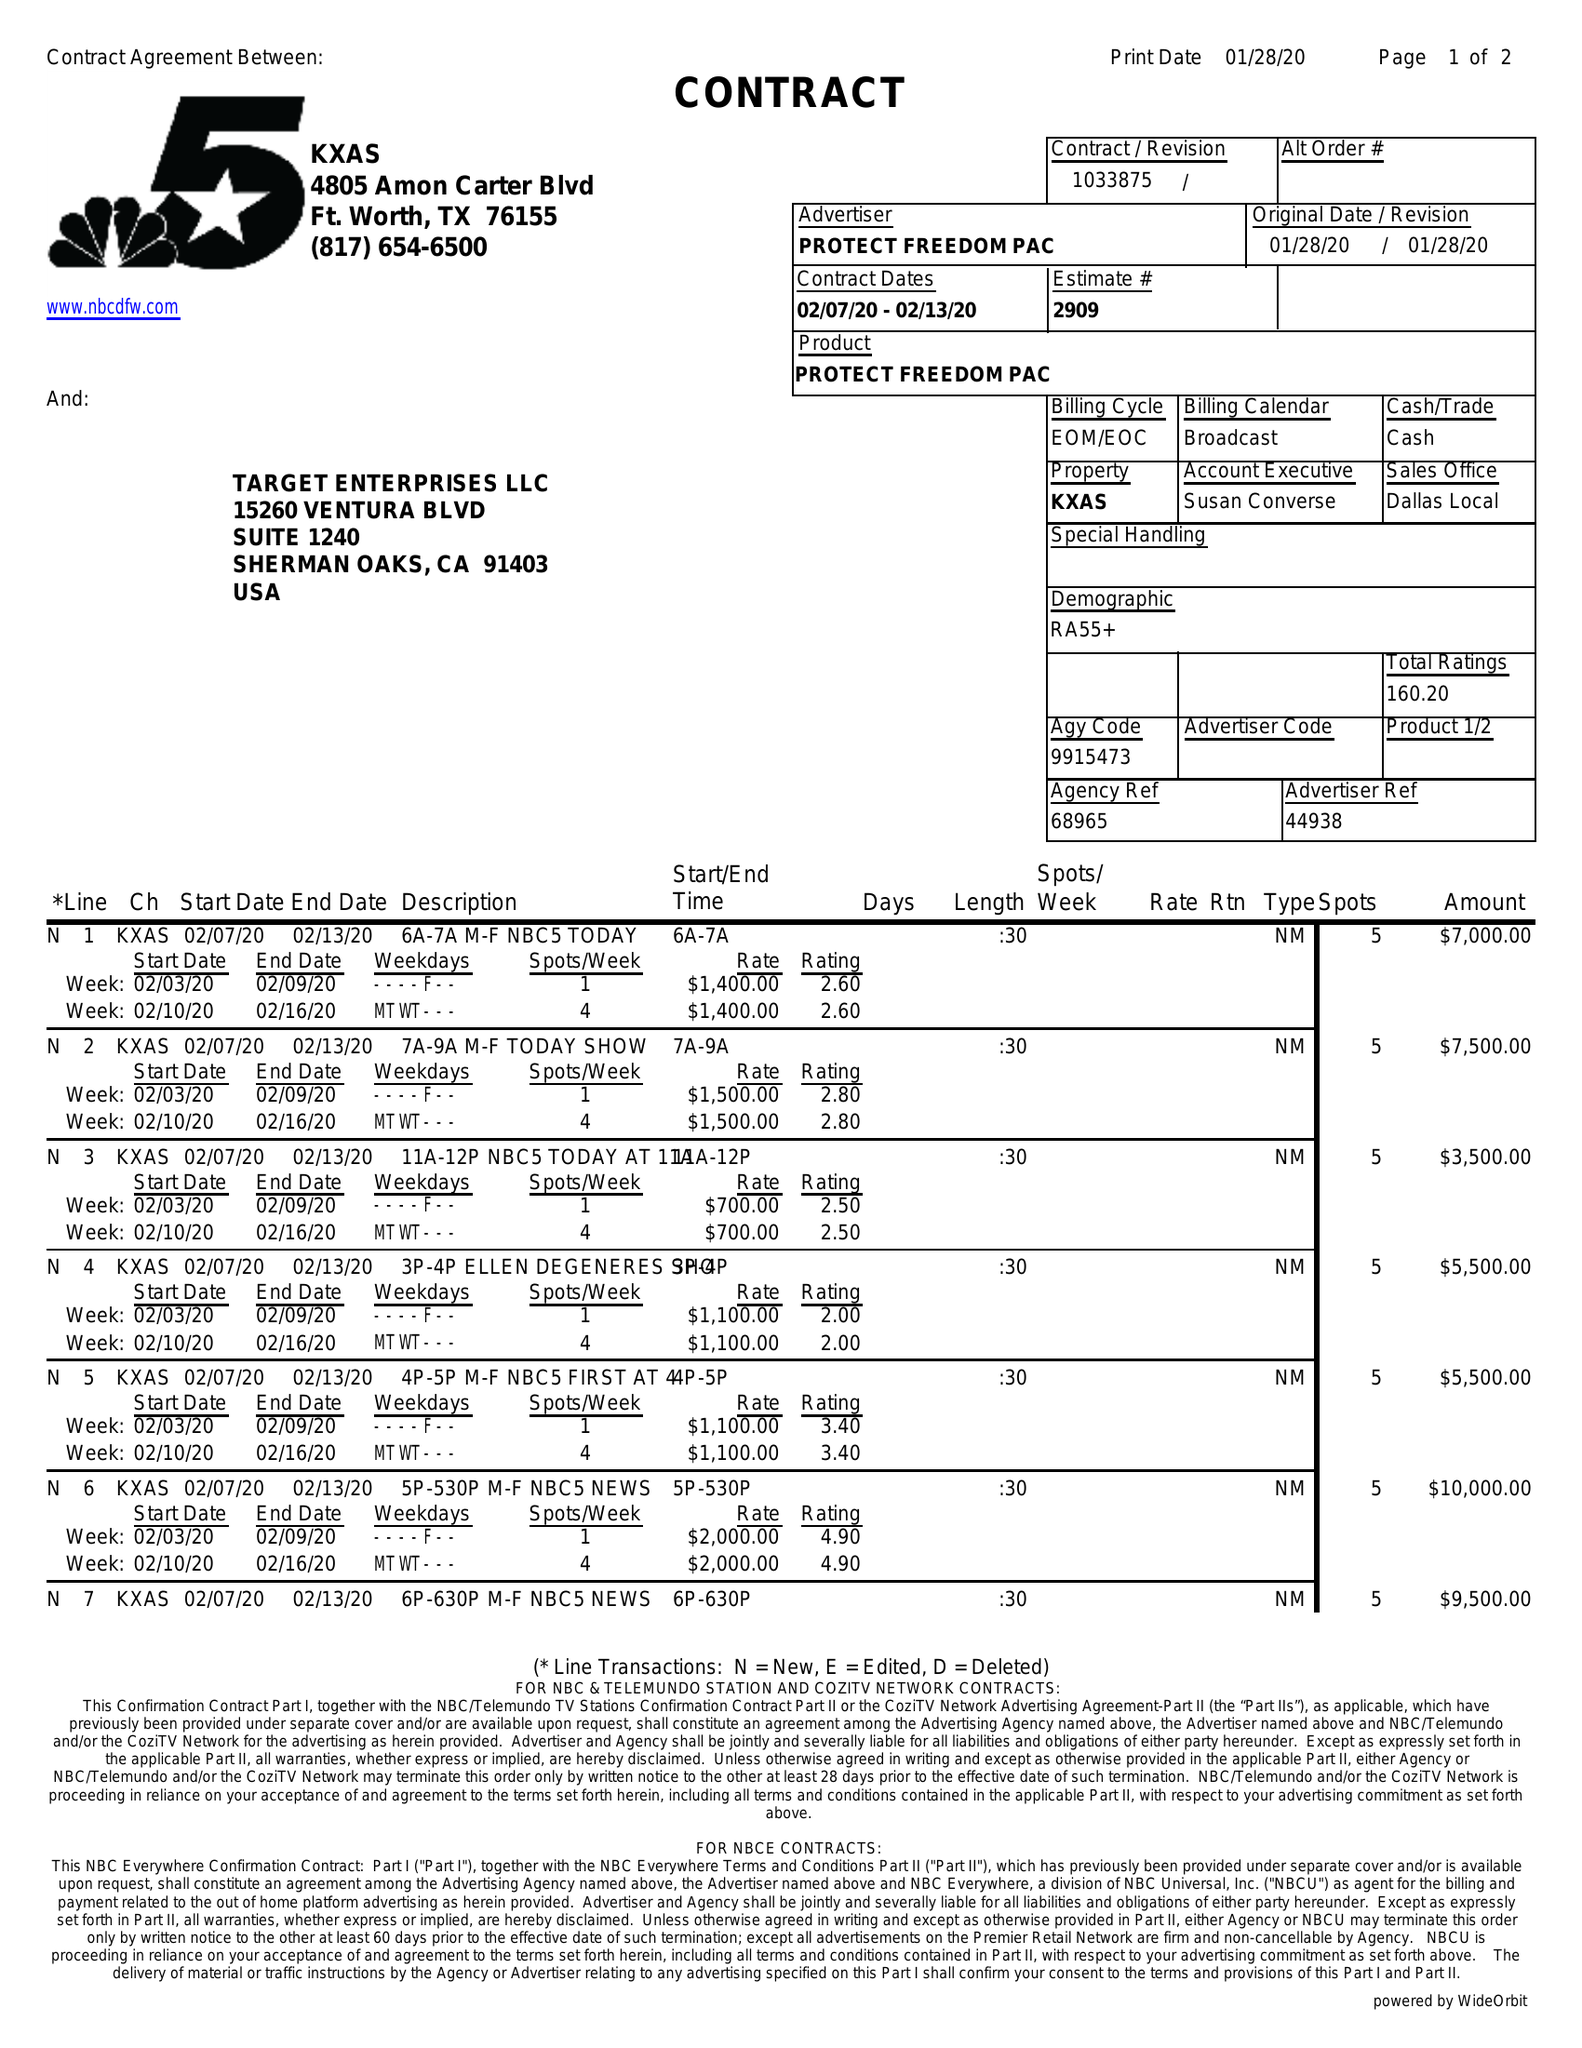What is the value for the gross_amount?
Answer the question using a single word or phrase. 69000.00 